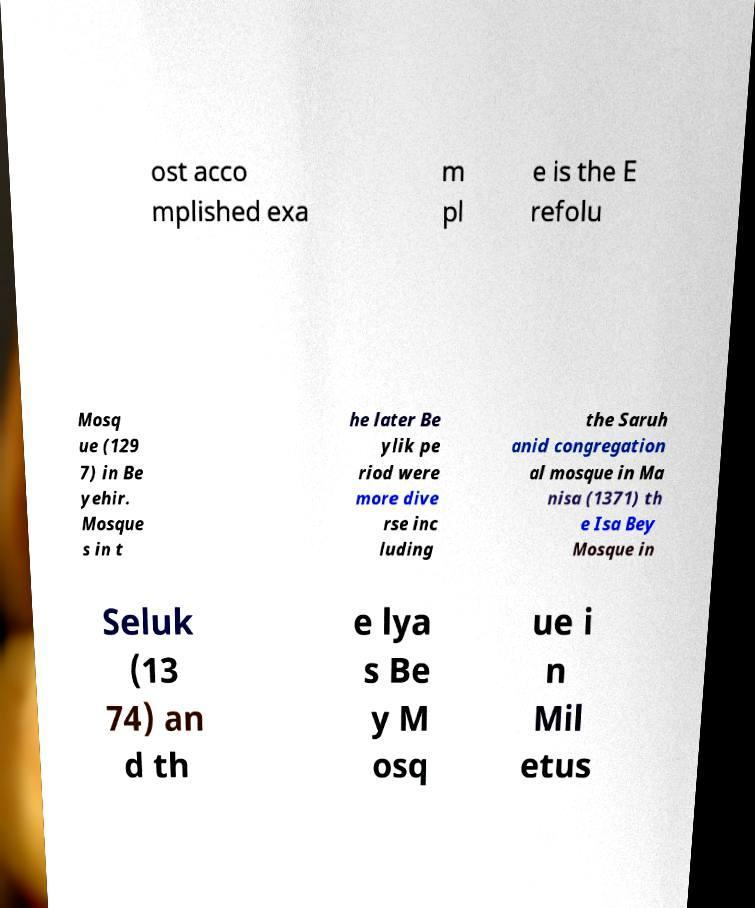What messages or text are displayed in this image? I need them in a readable, typed format. ost acco mplished exa m pl e is the E refolu Mosq ue (129 7) in Be yehir. Mosque s in t he later Be ylik pe riod were more dive rse inc luding the Saruh anid congregation al mosque in Ma nisa (1371) th e Isa Bey Mosque in Seluk (13 74) an d th e lya s Be y M osq ue i n Mil etus 